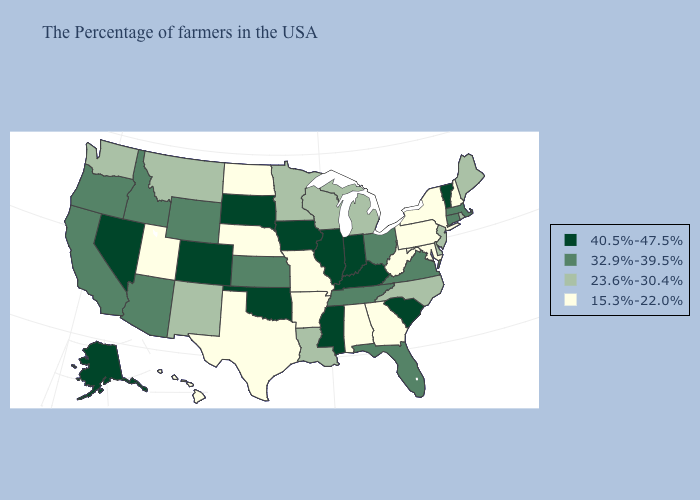What is the lowest value in the USA?
Answer briefly. 15.3%-22.0%. Which states have the lowest value in the Northeast?
Be succinct. New Hampshire, New York, Pennsylvania. Does the map have missing data?
Keep it brief. No. Does Kentucky have the lowest value in the USA?
Write a very short answer. No. Name the states that have a value in the range 23.6%-30.4%?
Write a very short answer. Maine, Rhode Island, New Jersey, Delaware, North Carolina, Michigan, Wisconsin, Louisiana, Minnesota, New Mexico, Montana, Washington. Does the first symbol in the legend represent the smallest category?
Short answer required. No. What is the value of Kentucky?
Keep it brief. 40.5%-47.5%. What is the value of Mississippi?
Be succinct. 40.5%-47.5%. Name the states that have a value in the range 40.5%-47.5%?
Concise answer only. Vermont, South Carolina, Kentucky, Indiana, Illinois, Mississippi, Iowa, Oklahoma, South Dakota, Colorado, Nevada, Alaska. What is the value of South Dakota?
Answer briefly. 40.5%-47.5%. What is the lowest value in the West?
Write a very short answer. 15.3%-22.0%. Which states hav the highest value in the MidWest?
Be succinct. Indiana, Illinois, Iowa, South Dakota. Does the first symbol in the legend represent the smallest category?
Answer briefly. No. What is the value of Virginia?
Write a very short answer. 32.9%-39.5%. What is the highest value in the USA?
Give a very brief answer. 40.5%-47.5%. 